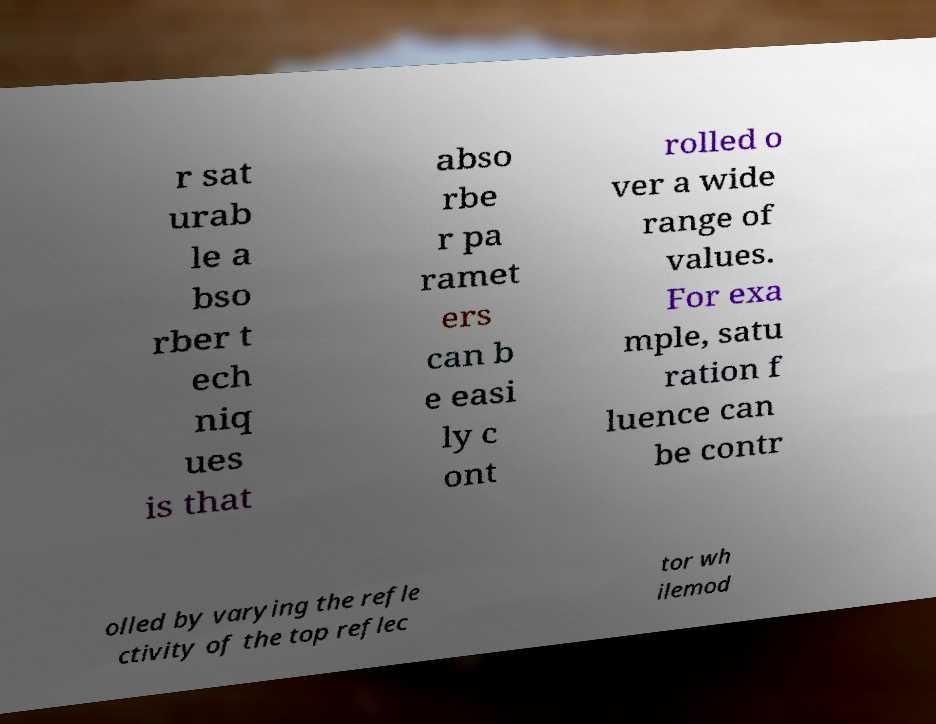I need the written content from this picture converted into text. Can you do that? r sat urab le a bso rber t ech niq ues is that abso rbe r pa ramet ers can b e easi ly c ont rolled o ver a wide range of values. For exa mple, satu ration f luence can be contr olled by varying the refle ctivity of the top reflec tor wh ilemod 